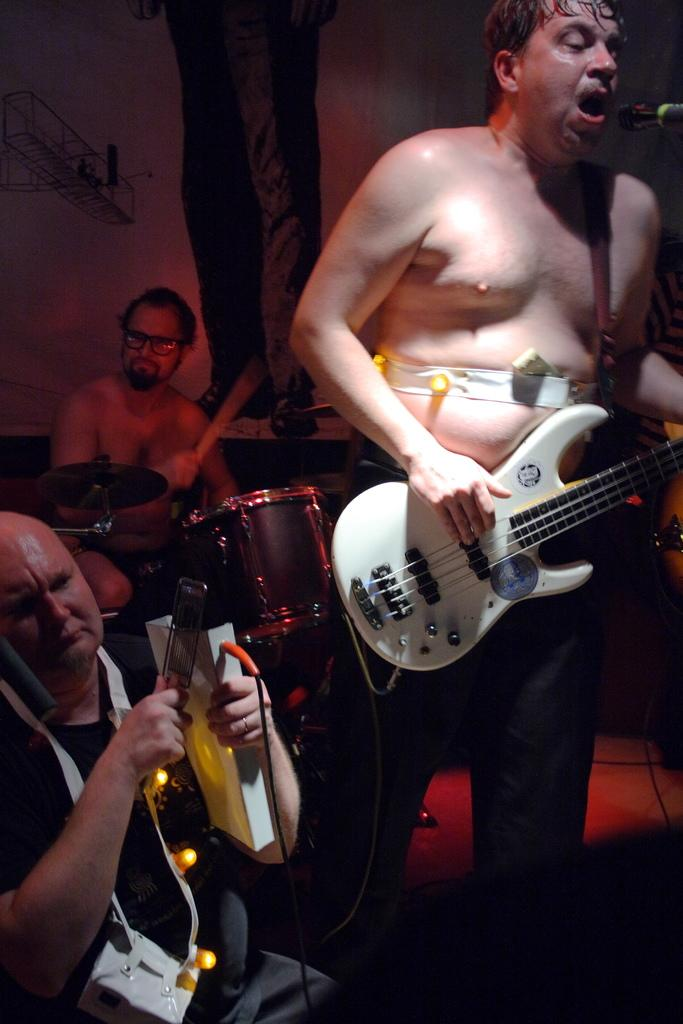What are the persons in the image doing? The persons in the image are playing music. How are the persons dressed in the image? The persons are without shirts in the image. Can you describe the position of the person in the left bottom corner? The person in the left bottom corner is sitting on the ground. What type of line can be seen connecting the persons in the image? There is no line connecting the persons in the image. What fictional character is present in the image? There are no fictional characters present in the image; it features real people playing music. 